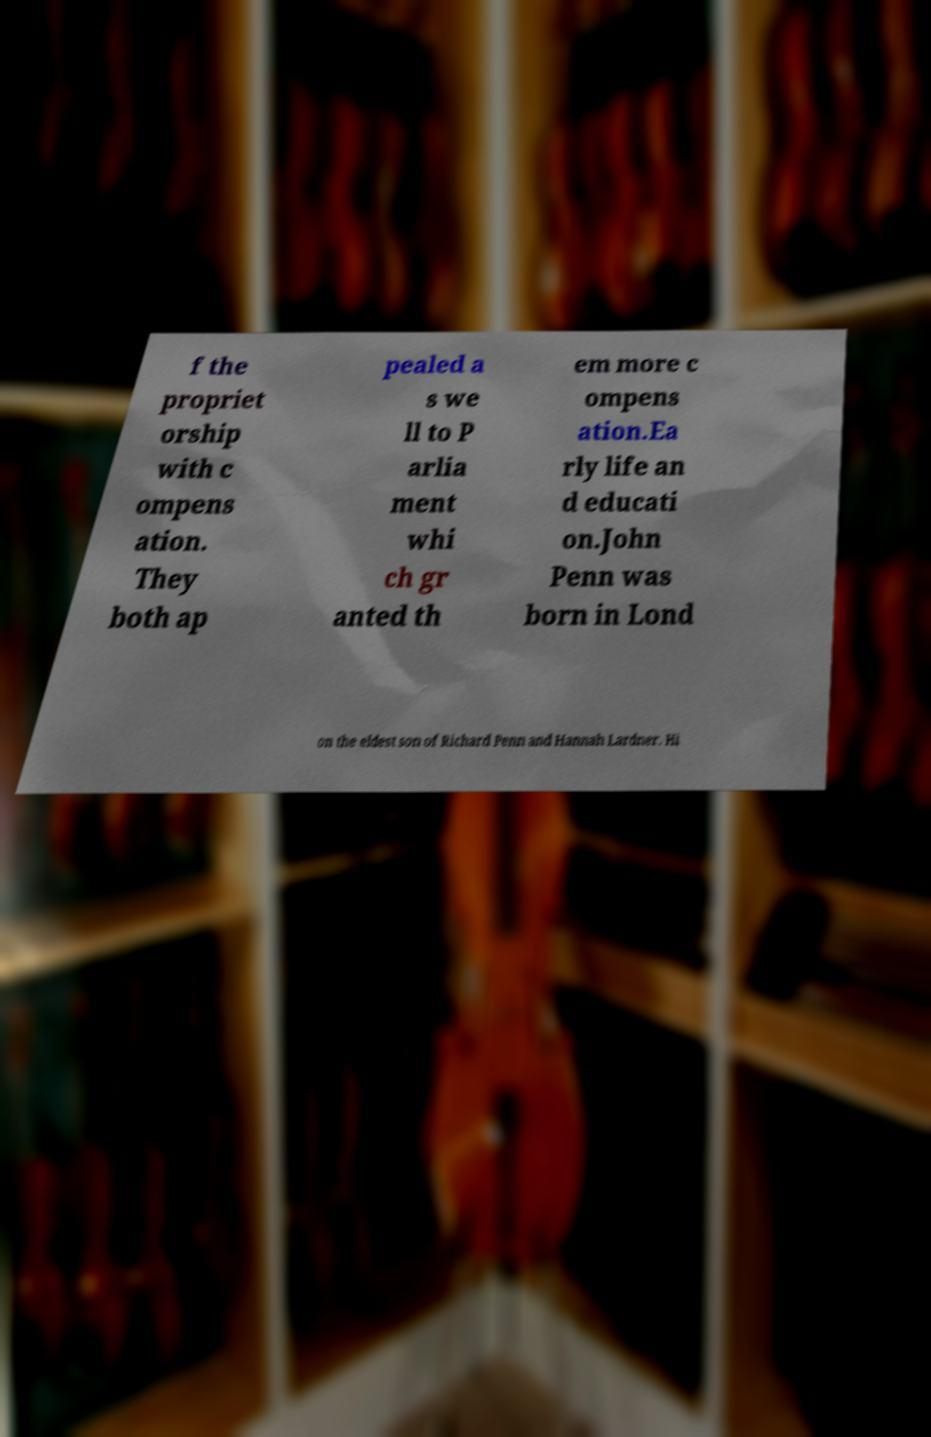Can you accurately transcribe the text from the provided image for me? f the propriet orship with c ompens ation. They both ap pealed a s we ll to P arlia ment whi ch gr anted th em more c ompens ation.Ea rly life an d educati on.John Penn was born in Lond on the eldest son of Richard Penn and Hannah Lardner. Hi 